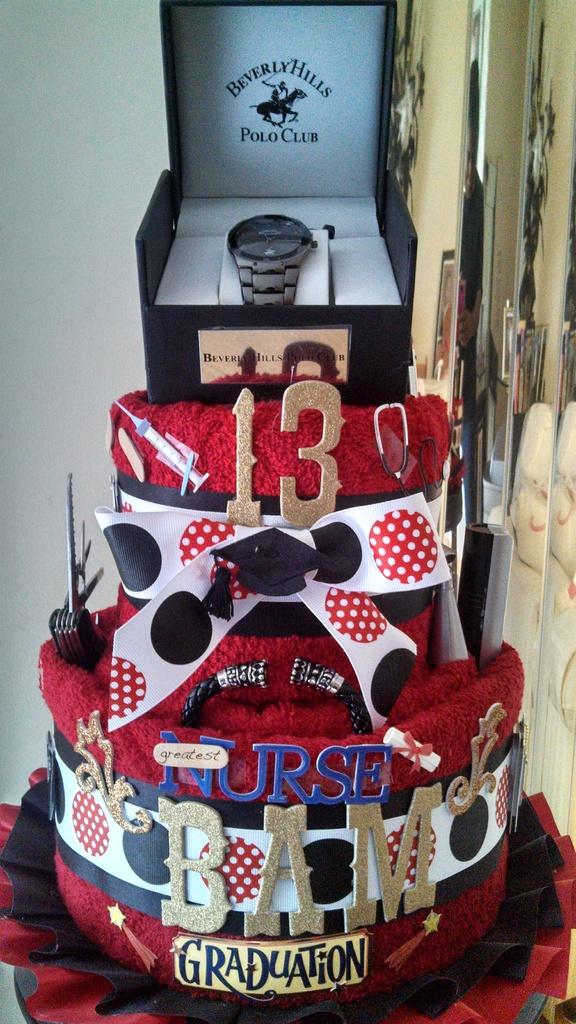What is the name of the polo club?
Your answer should be compact. Beverly hills. 